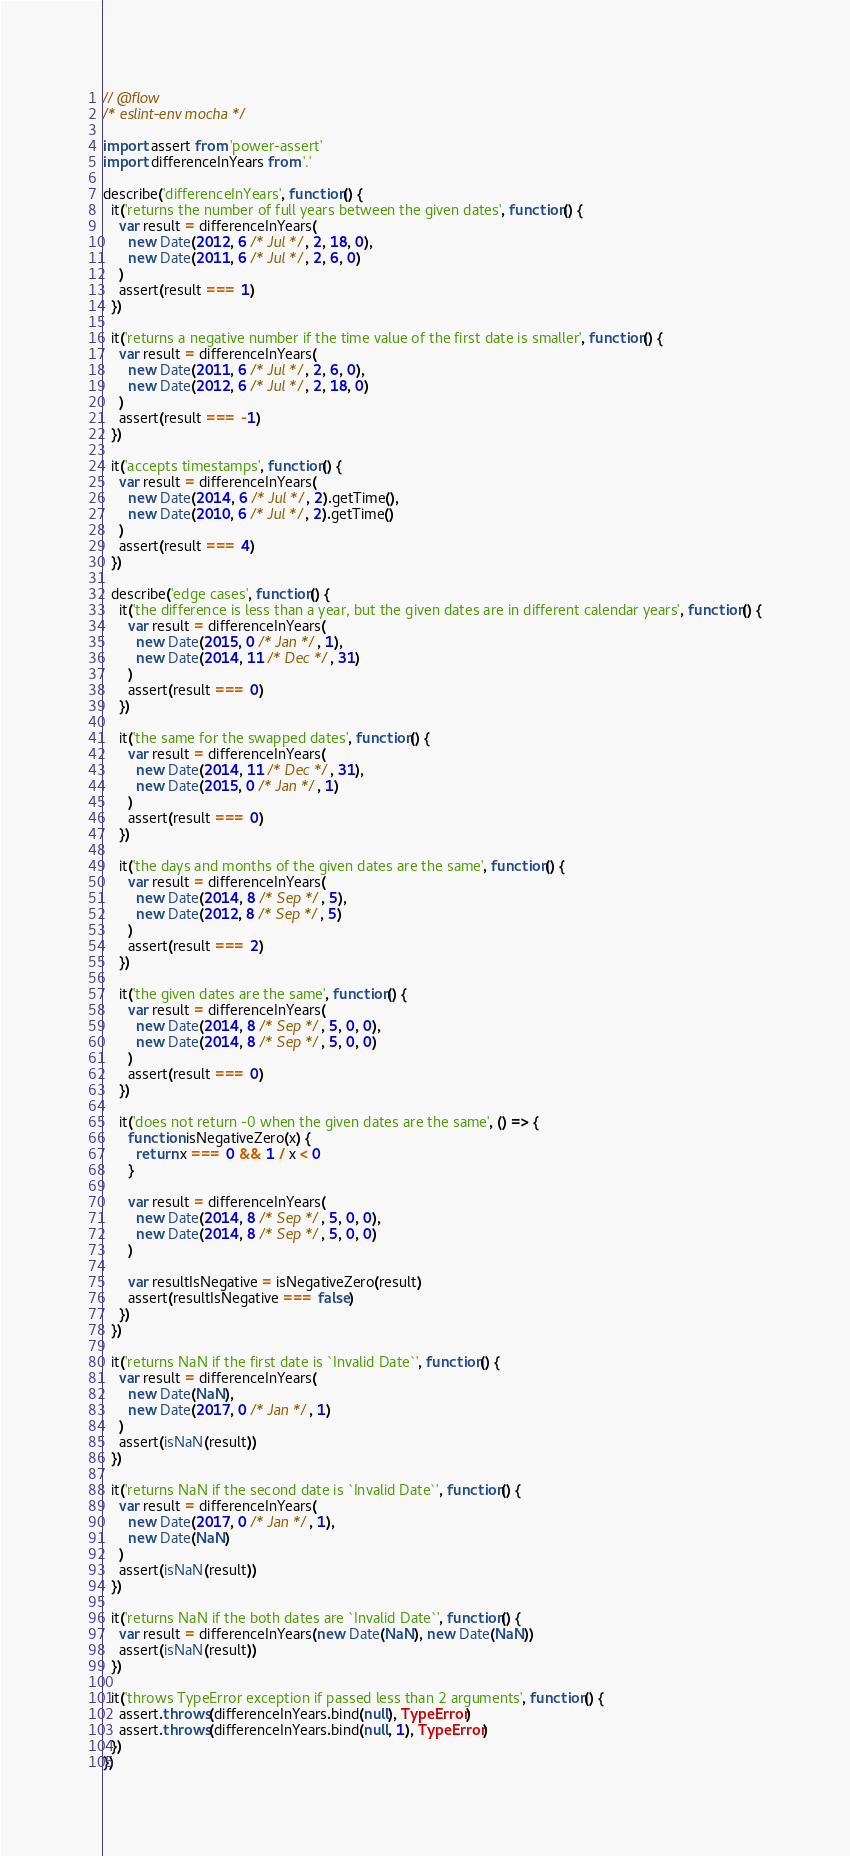<code> <loc_0><loc_0><loc_500><loc_500><_JavaScript_>// @flow
/* eslint-env mocha */

import assert from 'power-assert'
import differenceInYears from '.'

describe('differenceInYears', function() {
  it('returns the number of full years between the given dates', function() {
    var result = differenceInYears(
      new Date(2012, 6 /* Jul */, 2, 18, 0),
      new Date(2011, 6 /* Jul */, 2, 6, 0)
    )
    assert(result === 1)
  })

  it('returns a negative number if the time value of the first date is smaller', function() {
    var result = differenceInYears(
      new Date(2011, 6 /* Jul */, 2, 6, 0),
      new Date(2012, 6 /* Jul */, 2, 18, 0)
    )
    assert(result === -1)
  })

  it('accepts timestamps', function() {
    var result = differenceInYears(
      new Date(2014, 6 /* Jul */, 2).getTime(),
      new Date(2010, 6 /* Jul */, 2).getTime()
    )
    assert(result === 4)
  })

  describe('edge cases', function() {
    it('the difference is less than a year, but the given dates are in different calendar years', function() {
      var result = differenceInYears(
        new Date(2015, 0 /* Jan */, 1),
        new Date(2014, 11 /* Dec */, 31)
      )
      assert(result === 0)
    })

    it('the same for the swapped dates', function() {
      var result = differenceInYears(
        new Date(2014, 11 /* Dec */, 31),
        new Date(2015, 0 /* Jan */, 1)
      )
      assert(result === 0)
    })

    it('the days and months of the given dates are the same', function() {
      var result = differenceInYears(
        new Date(2014, 8 /* Sep */, 5),
        new Date(2012, 8 /* Sep */, 5)
      )
      assert(result === 2)
    })

    it('the given dates are the same', function() {
      var result = differenceInYears(
        new Date(2014, 8 /* Sep */, 5, 0, 0),
        new Date(2014, 8 /* Sep */, 5, 0, 0)
      )
      assert(result === 0)
    })

    it('does not return -0 when the given dates are the same', () => {
      function isNegativeZero(x) {
        return x === 0 && 1 / x < 0
      }

      var result = differenceInYears(
        new Date(2014, 8 /* Sep */, 5, 0, 0),
        new Date(2014, 8 /* Sep */, 5, 0, 0)
      )

      var resultIsNegative = isNegativeZero(result)
      assert(resultIsNegative === false)
    })
  })

  it('returns NaN if the first date is `Invalid Date`', function() {
    var result = differenceInYears(
      new Date(NaN),
      new Date(2017, 0 /* Jan */, 1)
    )
    assert(isNaN(result))
  })

  it('returns NaN if the second date is `Invalid Date`', function() {
    var result = differenceInYears(
      new Date(2017, 0 /* Jan */, 1),
      new Date(NaN)
    )
    assert(isNaN(result))
  })

  it('returns NaN if the both dates are `Invalid Date`', function() {
    var result = differenceInYears(new Date(NaN), new Date(NaN))
    assert(isNaN(result))
  })

  it('throws TypeError exception if passed less than 2 arguments', function() {
    assert.throws(differenceInYears.bind(null), TypeError)
    assert.throws(differenceInYears.bind(null, 1), TypeError)
  })
})
</code> 